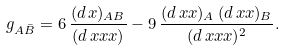<formula> <loc_0><loc_0><loc_500><loc_500>g _ { A \bar { B } } = 6 \, \frac { ( d \, x ) _ { A B } } { ( d \, x x x ) } - 9 \, \frac { ( d \, x x ) _ { A } \, ( d \, x x ) _ { B } } { ( d \, x x x ) ^ { 2 } } .</formula> 